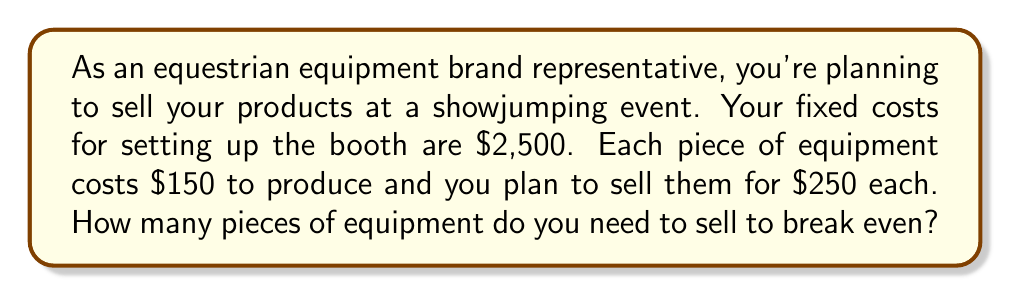Teach me how to tackle this problem. To solve this problem, we need to use the break-even formula:

$$ \text{Break-even point} = \frac{\text{Fixed Costs}}{\text{Price per unit} - \text{Variable Cost per unit}} $$

Let's define our variables:
- Fixed Costs (FC) = $2,500
- Price per unit (P) = $250
- Variable Cost per unit (VC) = $150

Now, let's substitute these values into the formula:

$$ \text{Break-even point} = \frac{2,500}{250 - 150} = \frac{2,500}{100} $$

Simplifying:

$$ \text{Break-even point} = 25 $$

To verify this result, we can calculate the total revenue and total costs at 25 units:

Total Revenue: $250 \times 25 = $6,250
Total Costs: $2,500 + ($150 \times 25) = $6,250

Since the total revenue equals the total costs at 25 units, this confirms our break-even point.
Answer: You need to sell 25 pieces of equipment to break even. 